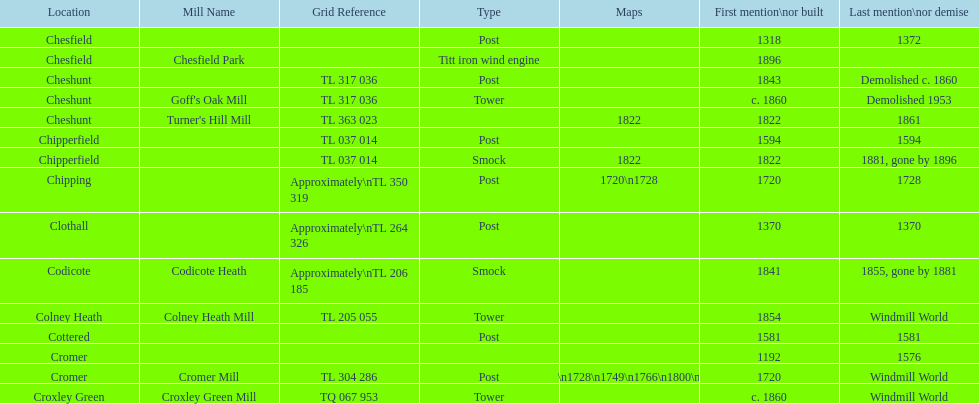How many mills were built or first mentioned after 1800? 8. 